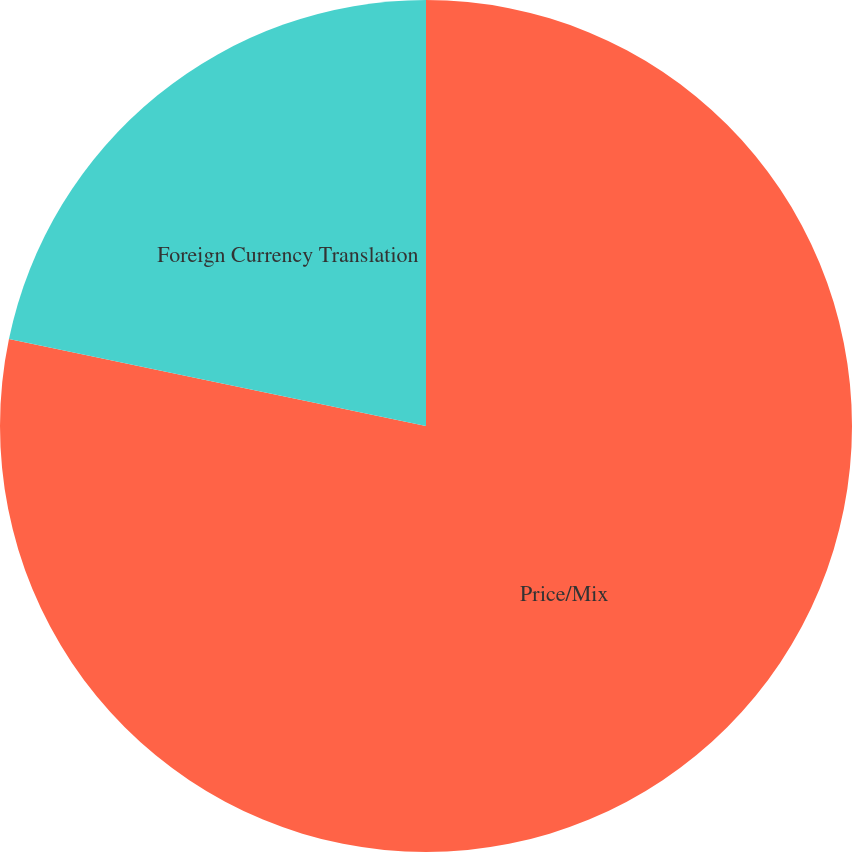Convert chart. <chart><loc_0><loc_0><loc_500><loc_500><pie_chart><fcel>Price/Mix<fcel>Foreign Currency Translation<nl><fcel>78.27%<fcel>21.73%<nl></chart> 